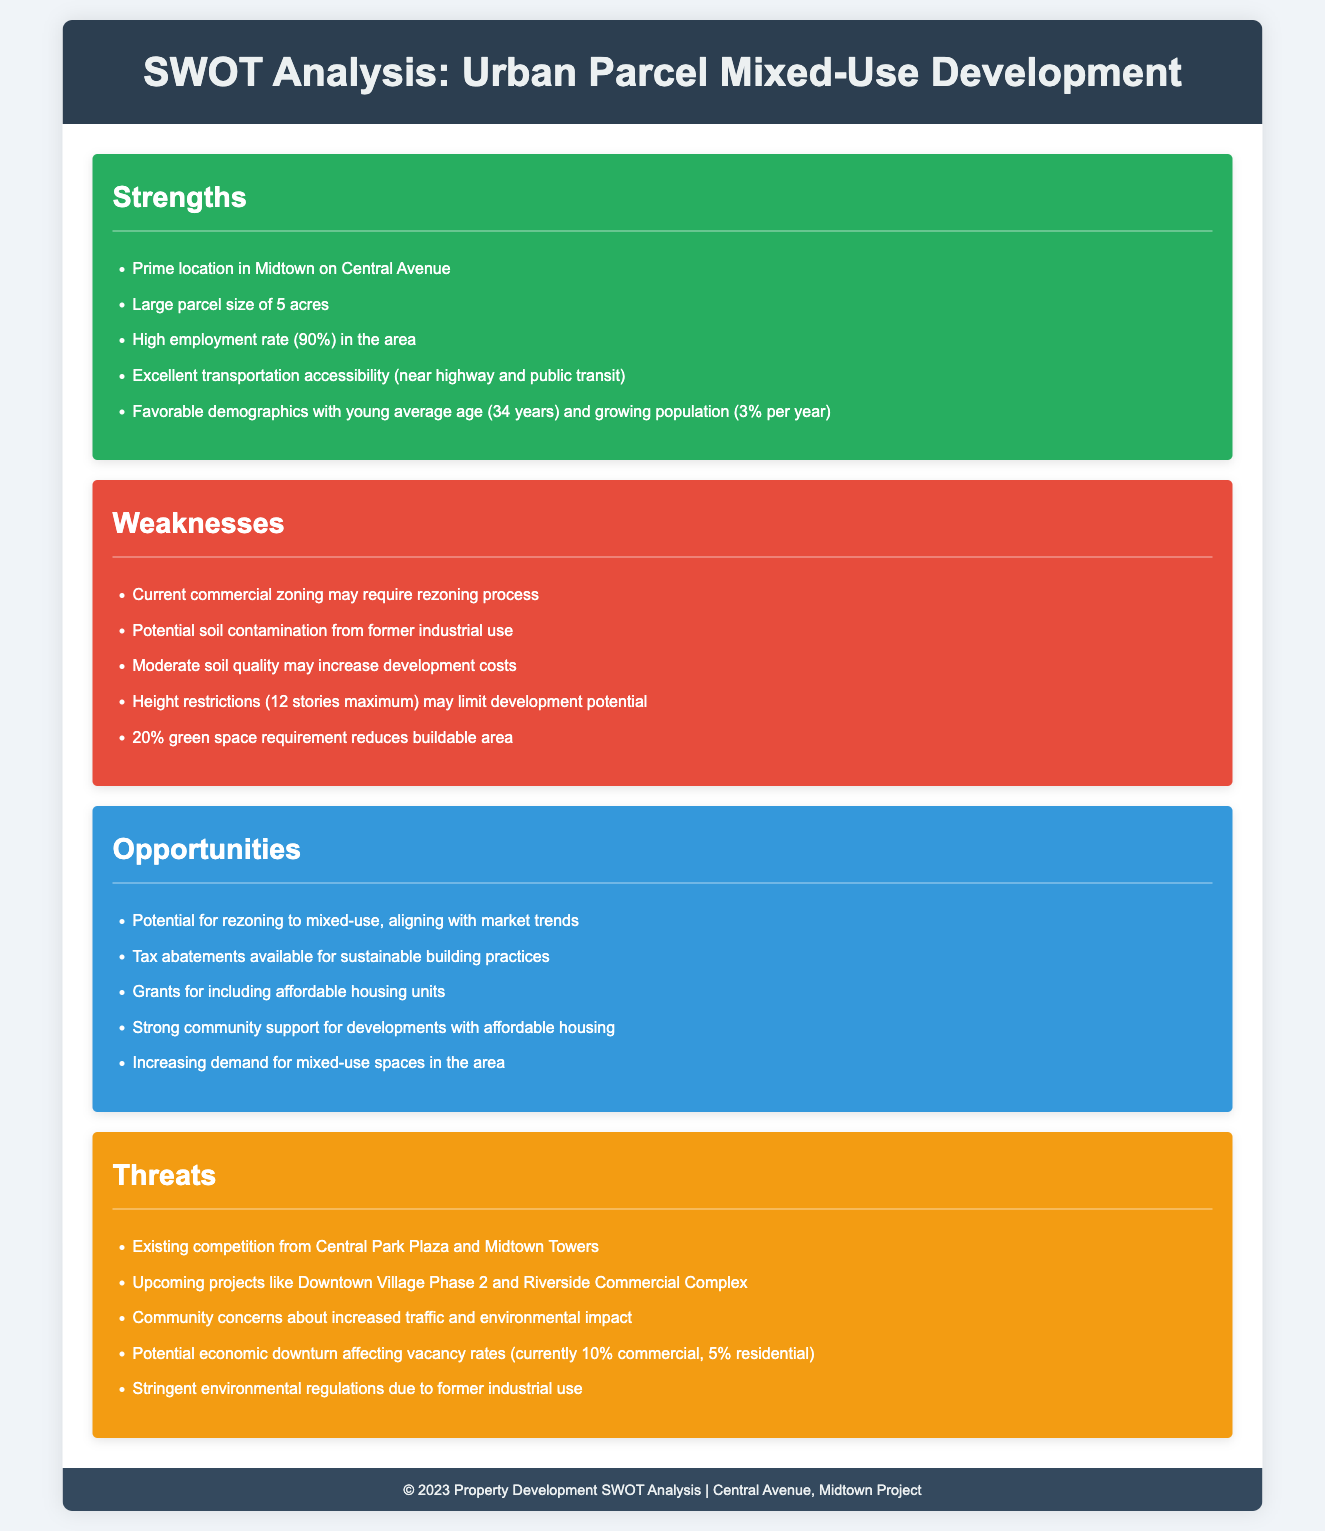What is the size of the urban parcel? The size of the parcel is mentioned as 5 acres in the strengths section.
Answer: 5 acres What is the maximum height restriction for development? The height restriction is provided in the weaknesses section.
Answer: 12 stories What is the employment rate in the area? The employment rate is mentioned in the strengths section.
Answer: 90% What type of grants are available for the development? Grants are mentioned in the opportunities section, specifically for including affordable housing units.
Answer: Affordable housing units What is the current vacancy rate for commercial properties? The current vacancy rate is detailed in the threats section.
Answer: 10% What annual population growth rate is indicated? The growth rate is found in the strengths section.
Answer: 3% What community concerns are raised regarding increased development? Community concerns are listed in the threats section.
Answer: Traffic and environmental impact What are the tax incentives available for the project? The tax incentives are mentioned in the opportunities section as tax abatements for sustainable practices.
Answer: Tax abatements What is one of the existing competitors for the project? Competitors are identified in the threats section.
Answer: Central Park Plaza 